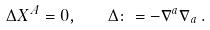<formula> <loc_0><loc_0><loc_500><loc_500>\Delta X ^ { A } = 0 , \quad \Delta \colon = - \nabla ^ { a } \nabla _ { a } \, .</formula> 